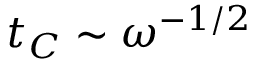Convert formula to latex. <formula><loc_0><loc_0><loc_500><loc_500>t _ { C } \sim \omega ^ { - 1 / 2 }</formula> 